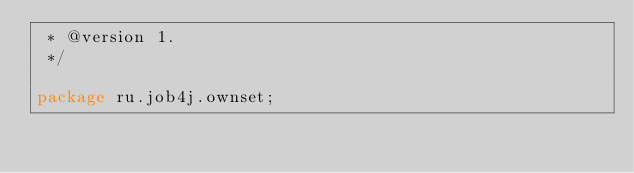<code> <loc_0><loc_0><loc_500><loc_500><_Java_> * @version 1.
 */

package ru.job4j.ownset;</code> 